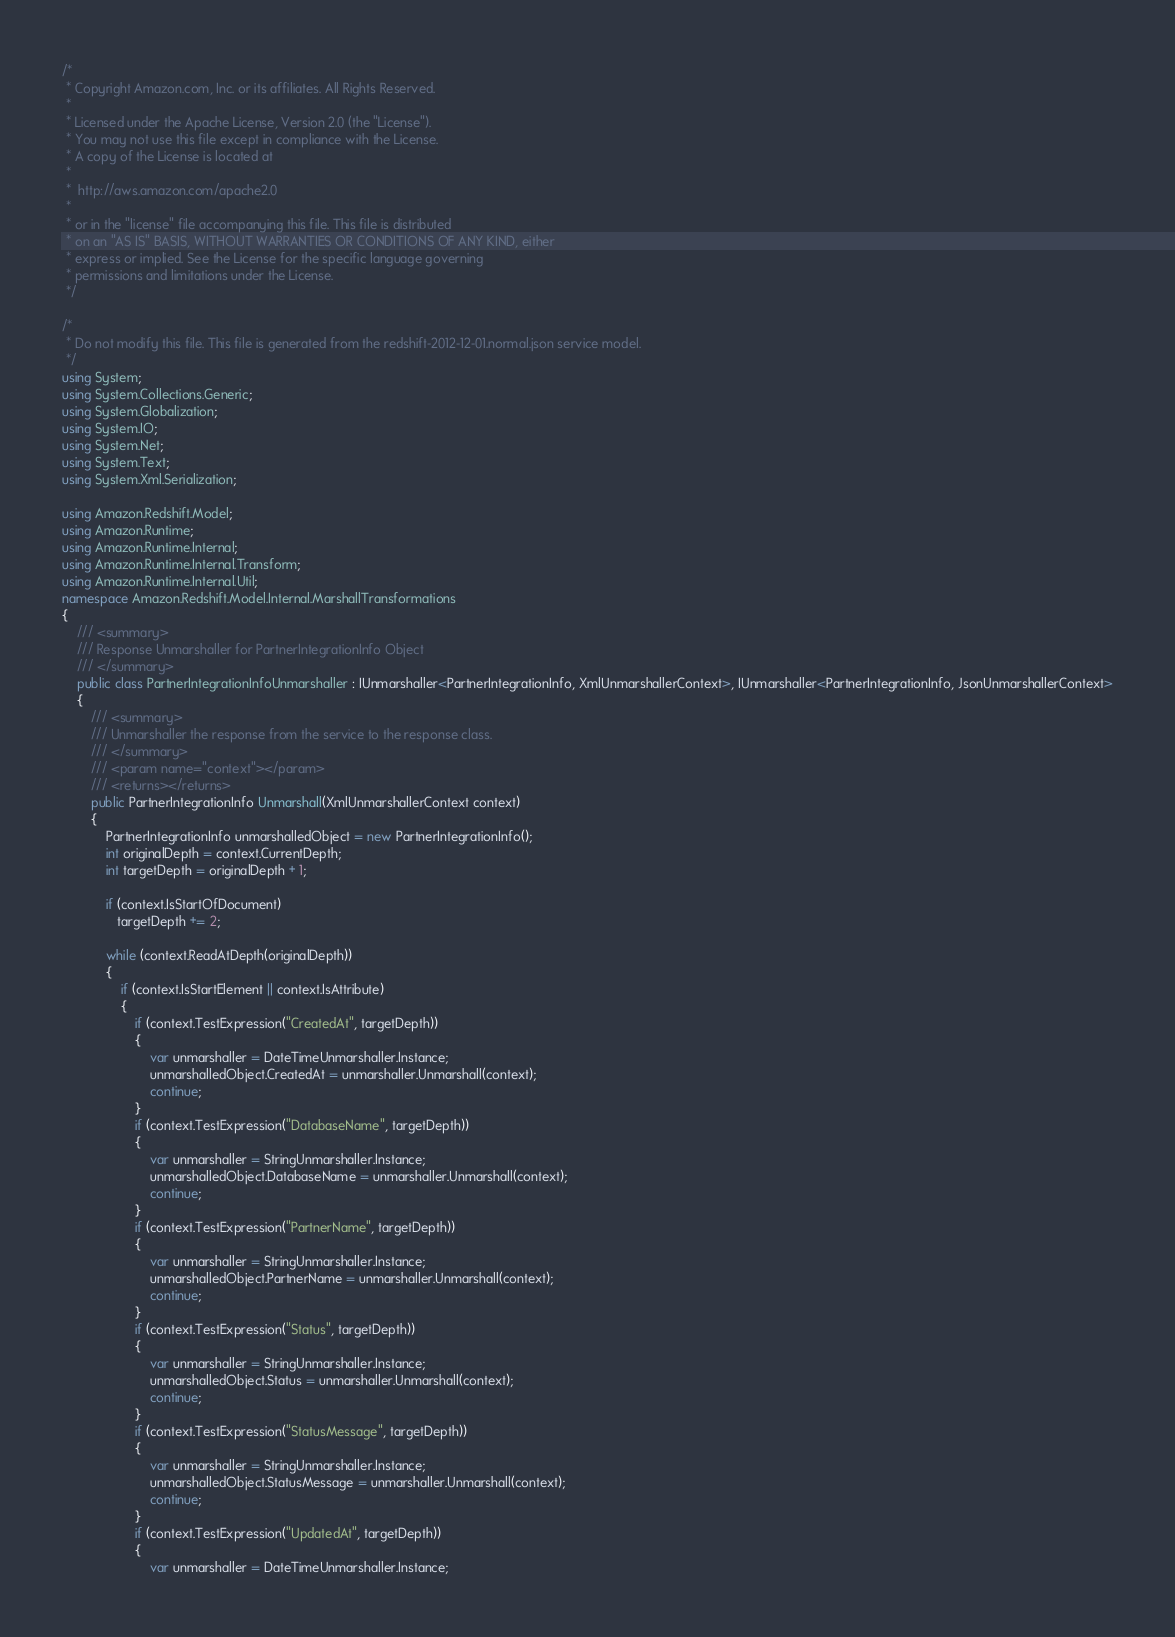<code> <loc_0><loc_0><loc_500><loc_500><_C#_>/*
 * Copyright Amazon.com, Inc. or its affiliates. All Rights Reserved.
 * 
 * Licensed under the Apache License, Version 2.0 (the "License").
 * You may not use this file except in compliance with the License.
 * A copy of the License is located at
 * 
 *  http://aws.amazon.com/apache2.0
 * 
 * or in the "license" file accompanying this file. This file is distributed
 * on an "AS IS" BASIS, WITHOUT WARRANTIES OR CONDITIONS OF ANY KIND, either
 * express or implied. See the License for the specific language governing
 * permissions and limitations under the License.
 */

/*
 * Do not modify this file. This file is generated from the redshift-2012-12-01.normal.json service model.
 */
using System;
using System.Collections.Generic;
using System.Globalization;
using System.IO;
using System.Net;
using System.Text;
using System.Xml.Serialization;

using Amazon.Redshift.Model;
using Amazon.Runtime;
using Amazon.Runtime.Internal;
using Amazon.Runtime.Internal.Transform;
using Amazon.Runtime.Internal.Util;
namespace Amazon.Redshift.Model.Internal.MarshallTransformations
{
    /// <summary>
    /// Response Unmarshaller for PartnerIntegrationInfo Object
    /// </summary>  
    public class PartnerIntegrationInfoUnmarshaller : IUnmarshaller<PartnerIntegrationInfo, XmlUnmarshallerContext>, IUnmarshaller<PartnerIntegrationInfo, JsonUnmarshallerContext>
    {
        /// <summary>
        /// Unmarshaller the response from the service to the response class.
        /// </summary>  
        /// <param name="context"></param>
        /// <returns></returns>
        public PartnerIntegrationInfo Unmarshall(XmlUnmarshallerContext context)
        {
            PartnerIntegrationInfo unmarshalledObject = new PartnerIntegrationInfo();
            int originalDepth = context.CurrentDepth;
            int targetDepth = originalDepth + 1;
            
            if (context.IsStartOfDocument) 
               targetDepth += 2;
            
            while (context.ReadAtDepth(originalDepth))
            {
                if (context.IsStartElement || context.IsAttribute)
                {
                    if (context.TestExpression("CreatedAt", targetDepth))
                    {
                        var unmarshaller = DateTimeUnmarshaller.Instance;
                        unmarshalledObject.CreatedAt = unmarshaller.Unmarshall(context);
                        continue;
                    }
                    if (context.TestExpression("DatabaseName", targetDepth))
                    {
                        var unmarshaller = StringUnmarshaller.Instance;
                        unmarshalledObject.DatabaseName = unmarshaller.Unmarshall(context);
                        continue;
                    }
                    if (context.TestExpression("PartnerName", targetDepth))
                    {
                        var unmarshaller = StringUnmarshaller.Instance;
                        unmarshalledObject.PartnerName = unmarshaller.Unmarshall(context);
                        continue;
                    }
                    if (context.TestExpression("Status", targetDepth))
                    {
                        var unmarshaller = StringUnmarshaller.Instance;
                        unmarshalledObject.Status = unmarshaller.Unmarshall(context);
                        continue;
                    }
                    if (context.TestExpression("StatusMessage", targetDepth))
                    {
                        var unmarshaller = StringUnmarshaller.Instance;
                        unmarshalledObject.StatusMessage = unmarshaller.Unmarshall(context);
                        continue;
                    }
                    if (context.TestExpression("UpdatedAt", targetDepth))
                    {
                        var unmarshaller = DateTimeUnmarshaller.Instance;</code> 